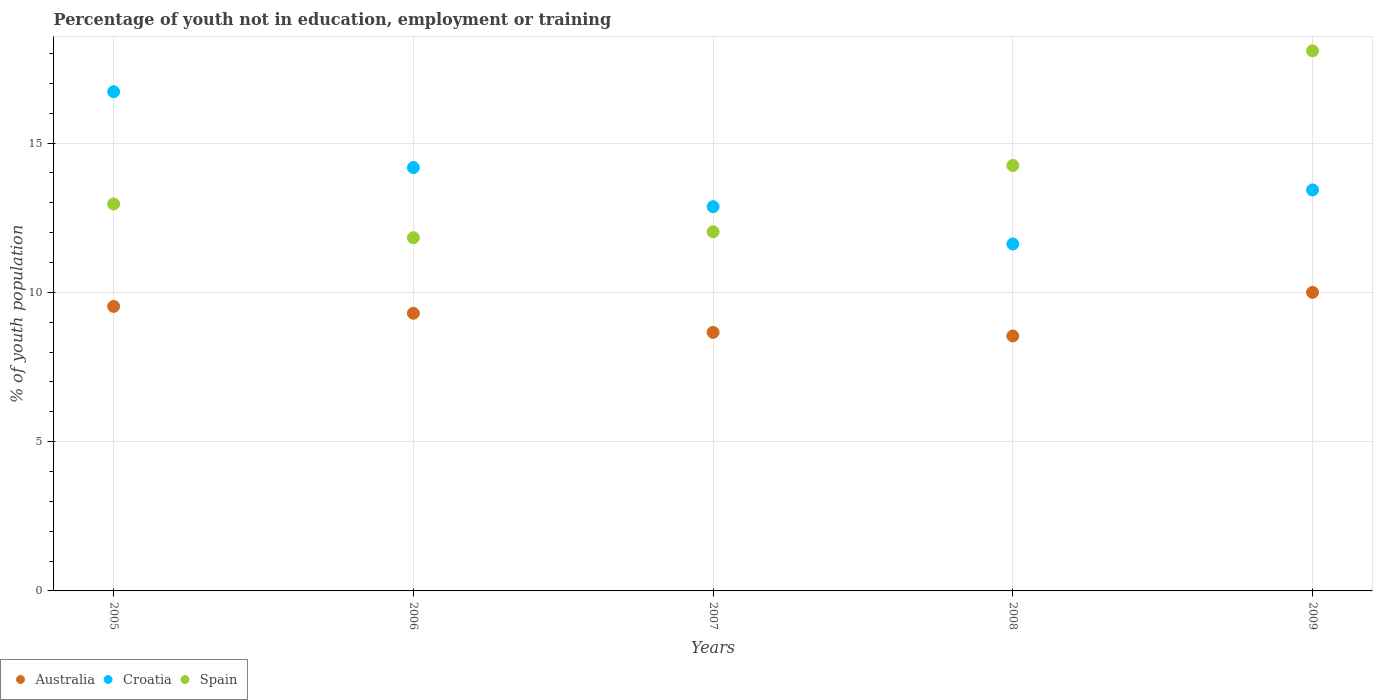What is the percentage of unemployed youth population in in Croatia in 2009?
Ensure brevity in your answer.  13.43. Across all years, what is the maximum percentage of unemployed youth population in in Croatia?
Ensure brevity in your answer.  16.72. Across all years, what is the minimum percentage of unemployed youth population in in Spain?
Offer a very short reply. 11.83. In which year was the percentage of unemployed youth population in in Australia minimum?
Provide a short and direct response. 2008. What is the total percentage of unemployed youth population in in Croatia in the graph?
Your answer should be very brief. 68.82. What is the difference between the percentage of unemployed youth population in in Australia in 2005 and that in 2006?
Provide a short and direct response. 0.23. What is the difference between the percentage of unemployed youth population in in Australia in 2007 and the percentage of unemployed youth population in in Spain in 2009?
Your response must be concise. -9.43. What is the average percentage of unemployed youth population in in Spain per year?
Offer a terse response. 13.83. In the year 2005, what is the difference between the percentage of unemployed youth population in in Spain and percentage of unemployed youth population in in Australia?
Offer a terse response. 3.43. In how many years, is the percentage of unemployed youth population in in Croatia greater than 17 %?
Offer a terse response. 0. What is the ratio of the percentage of unemployed youth population in in Australia in 2005 to that in 2008?
Your answer should be compact. 1.12. What is the difference between the highest and the second highest percentage of unemployed youth population in in Spain?
Give a very brief answer. 3.84. What is the difference between the highest and the lowest percentage of unemployed youth population in in Australia?
Provide a succinct answer. 1.46. Is the sum of the percentage of unemployed youth population in in Australia in 2006 and 2007 greater than the maximum percentage of unemployed youth population in in Croatia across all years?
Your answer should be compact. Yes. Is it the case that in every year, the sum of the percentage of unemployed youth population in in Spain and percentage of unemployed youth population in in Croatia  is greater than the percentage of unemployed youth population in in Australia?
Your answer should be compact. Yes. Does the percentage of unemployed youth population in in Australia monotonically increase over the years?
Your answer should be compact. No. Is the percentage of unemployed youth population in in Australia strictly greater than the percentage of unemployed youth population in in Spain over the years?
Ensure brevity in your answer.  No. Is the percentage of unemployed youth population in in Croatia strictly less than the percentage of unemployed youth population in in Australia over the years?
Provide a short and direct response. No. How many dotlines are there?
Provide a succinct answer. 3. What is the difference between two consecutive major ticks on the Y-axis?
Your response must be concise. 5. Are the values on the major ticks of Y-axis written in scientific E-notation?
Ensure brevity in your answer.  No. Where does the legend appear in the graph?
Offer a very short reply. Bottom left. How many legend labels are there?
Your response must be concise. 3. How are the legend labels stacked?
Make the answer very short. Horizontal. What is the title of the graph?
Your answer should be compact. Percentage of youth not in education, employment or training. What is the label or title of the Y-axis?
Ensure brevity in your answer.  % of youth population. What is the % of youth population in Australia in 2005?
Keep it short and to the point. 9.53. What is the % of youth population in Croatia in 2005?
Your answer should be compact. 16.72. What is the % of youth population in Spain in 2005?
Make the answer very short. 12.96. What is the % of youth population of Australia in 2006?
Give a very brief answer. 9.3. What is the % of youth population of Croatia in 2006?
Provide a succinct answer. 14.18. What is the % of youth population in Spain in 2006?
Your answer should be very brief. 11.83. What is the % of youth population in Australia in 2007?
Your answer should be compact. 8.66. What is the % of youth population of Croatia in 2007?
Provide a short and direct response. 12.87. What is the % of youth population of Spain in 2007?
Offer a terse response. 12.03. What is the % of youth population in Australia in 2008?
Your answer should be compact. 8.54. What is the % of youth population in Croatia in 2008?
Keep it short and to the point. 11.62. What is the % of youth population in Spain in 2008?
Your answer should be compact. 14.25. What is the % of youth population in Croatia in 2009?
Your answer should be very brief. 13.43. What is the % of youth population of Spain in 2009?
Ensure brevity in your answer.  18.09. Across all years, what is the maximum % of youth population of Australia?
Provide a short and direct response. 10. Across all years, what is the maximum % of youth population of Croatia?
Provide a short and direct response. 16.72. Across all years, what is the maximum % of youth population of Spain?
Offer a terse response. 18.09. Across all years, what is the minimum % of youth population of Australia?
Your answer should be very brief. 8.54. Across all years, what is the minimum % of youth population in Croatia?
Ensure brevity in your answer.  11.62. Across all years, what is the minimum % of youth population of Spain?
Give a very brief answer. 11.83. What is the total % of youth population in Australia in the graph?
Offer a terse response. 46.03. What is the total % of youth population in Croatia in the graph?
Keep it short and to the point. 68.82. What is the total % of youth population of Spain in the graph?
Your response must be concise. 69.16. What is the difference between the % of youth population of Australia in 2005 and that in 2006?
Offer a very short reply. 0.23. What is the difference between the % of youth population in Croatia in 2005 and that in 2006?
Give a very brief answer. 2.54. What is the difference between the % of youth population of Spain in 2005 and that in 2006?
Provide a short and direct response. 1.13. What is the difference between the % of youth population in Australia in 2005 and that in 2007?
Ensure brevity in your answer.  0.87. What is the difference between the % of youth population of Croatia in 2005 and that in 2007?
Your answer should be compact. 3.85. What is the difference between the % of youth population of Spain in 2005 and that in 2008?
Your response must be concise. -1.29. What is the difference between the % of youth population of Australia in 2005 and that in 2009?
Provide a short and direct response. -0.47. What is the difference between the % of youth population of Croatia in 2005 and that in 2009?
Give a very brief answer. 3.29. What is the difference between the % of youth population of Spain in 2005 and that in 2009?
Give a very brief answer. -5.13. What is the difference between the % of youth population in Australia in 2006 and that in 2007?
Your answer should be compact. 0.64. What is the difference between the % of youth population in Croatia in 2006 and that in 2007?
Your answer should be very brief. 1.31. What is the difference between the % of youth population in Spain in 2006 and that in 2007?
Give a very brief answer. -0.2. What is the difference between the % of youth population in Australia in 2006 and that in 2008?
Keep it short and to the point. 0.76. What is the difference between the % of youth population of Croatia in 2006 and that in 2008?
Give a very brief answer. 2.56. What is the difference between the % of youth population in Spain in 2006 and that in 2008?
Offer a very short reply. -2.42. What is the difference between the % of youth population of Australia in 2006 and that in 2009?
Provide a short and direct response. -0.7. What is the difference between the % of youth population of Spain in 2006 and that in 2009?
Your answer should be compact. -6.26. What is the difference between the % of youth population of Australia in 2007 and that in 2008?
Your answer should be very brief. 0.12. What is the difference between the % of youth population of Spain in 2007 and that in 2008?
Offer a terse response. -2.22. What is the difference between the % of youth population of Australia in 2007 and that in 2009?
Give a very brief answer. -1.34. What is the difference between the % of youth population in Croatia in 2007 and that in 2009?
Offer a terse response. -0.56. What is the difference between the % of youth population of Spain in 2007 and that in 2009?
Ensure brevity in your answer.  -6.06. What is the difference between the % of youth population of Australia in 2008 and that in 2009?
Keep it short and to the point. -1.46. What is the difference between the % of youth population of Croatia in 2008 and that in 2009?
Offer a very short reply. -1.81. What is the difference between the % of youth population of Spain in 2008 and that in 2009?
Provide a short and direct response. -3.84. What is the difference between the % of youth population of Australia in 2005 and the % of youth population of Croatia in 2006?
Provide a succinct answer. -4.65. What is the difference between the % of youth population in Croatia in 2005 and the % of youth population in Spain in 2006?
Give a very brief answer. 4.89. What is the difference between the % of youth population in Australia in 2005 and the % of youth population in Croatia in 2007?
Ensure brevity in your answer.  -3.34. What is the difference between the % of youth population of Croatia in 2005 and the % of youth population of Spain in 2007?
Make the answer very short. 4.69. What is the difference between the % of youth population in Australia in 2005 and the % of youth population in Croatia in 2008?
Give a very brief answer. -2.09. What is the difference between the % of youth population of Australia in 2005 and the % of youth population of Spain in 2008?
Your answer should be very brief. -4.72. What is the difference between the % of youth population of Croatia in 2005 and the % of youth population of Spain in 2008?
Provide a short and direct response. 2.47. What is the difference between the % of youth population of Australia in 2005 and the % of youth population of Spain in 2009?
Provide a short and direct response. -8.56. What is the difference between the % of youth population of Croatia in 2005 and the % of youth population of Spain in 2009?
Offer a very short reply. -1.37. What is the difference between the % of youth population of Australia in 2006 and the % of youth population of Croatia in 2007?
Keep it short and to the point. -3.57. What is the difference between the % of youth population in Australia in 2006 and the % of youth population in Spain in 2007?
Offer a very short reply. -2.73. What is the difference between the % of youth population of Croatia in 2006 and the % of youth population of Spain in 2007?
Your answer should be very brief. 2.15. What is the difference between the % of youth population in Australia in 2006 and the % of youth population in Croatia in 2008?
Ensure brevity in your answer.  -2.32. What is the difference between the % of youth population in Australia in 2006 and the % of youth population in Spain in 2008?
Provide a succinct answer. -4.95. What is the difference between the % of youth population in Croatia in 2006 and the % of youth population in Spain in 2008?
Offer a very short reply. -0.07. What is the difference between the % of youth population in Australia in 2006 and the % of youth population in Croatia in 2009?
Make the answer very short. -4.13. What is the difference between the % of youth population of Australia in 2006 and the % of youth population of Spain in 2009?
Your response must be concise. -8.79. What is the difference between the % of youth population in Croatia in 2006 and the % of youth population in Spain in 2009?
Offer a terse response. -3.91. What is the difference between the % of youth population of Australia in 2007 and the % of youth population of Croatia in 2008?
Offer a terse response. -2.96. What is the difference between the % of youth population in Australia in 2007 and the % of youth population in Spain in 2008?
Provide a short and direct response. -5.59. What is the difference between the % of youth population in Croatia in 2007 and the % of youth population in Spain in 2008?
Keep it short and to the point. -1.38. What is the difference between the % of youth population of Australia in 2007 and the % of youth population of Croatia in 2009?
Your response must be concise. -4.77. What is the difference between the % of youth population in Australia in 2007 and the % of youth population in Spain in 2009?
Provide a succinct answer. -9.43. What is the difference between the % of youth population of Croatia in 2007 and the % of youth population of Spain in 2009?
Give a very brief answer. -5.22. What is the difference between the % of youth population in Australia in 2008 and the % of youth population in Croatia in 2009?
Give a very brief answer. -4.89. What is the difference between the % of youth population of Australia in 2008 and the % of youth population of Spain in 2009?
Give a very brief answer. -9.55. What is the difference between the % of youth population in Croatia in 2008 and the % of youth population in Spain in 2009?
Keep it short and to the point. -6.47. What is the average % of youth population of Australia per year?
Offer a terse response. 9.21. What is the average % of youth population of Croatia per year?
Your answer should be very brief. 13.76. What is the average % of youth population in Spain per year?
Make the answer very short. 13.83. In the year 2005, what is the difference between the % of youth population of Australia and % of youth population of Croatia?
Provide a short and direct response. -7.19. In the year 2005, what is the difference between the % of youth population of Australia and % of youth population of Spain?
Make the answer very short. -3.43. In the year 2005, what is the difference between the % of youth population in Croatia and % of youth population in Spain?
Make the answer very short. 3.76. In the year 2006, what is the difference between the % of youth population of Australia and % of youth population of Croatia?
Make the answer very short. -4.88. In the year 2006, what is the difference between the % of youth population in Australia and % of youth population in Spain?
Keep it short and to the point. -2.53. In the year 2006, what is the difference between the % of youth population in Croatia and % of youth population in Spain?
Ensure brevity in your answer.  2.35. In the year 2007, what is the difference between the % of youth population in Australia and % of youth population in Croatia?
Offer a very short reply. -4.21. In the year 2007, what is the difference between the % of youth population of Australia and % of youth population of Spain?
Ensure brevity in your answer.  -3.37. In the year 2007, what is the difference between the % of youth population of Croatia and % of youth population of Spain?
Offer a very short reply. 0.84. In the year 2008, what is the difference between the % of youth population of Australia and % of youth population of Croatia?
Offer a very short reply. -3.08. In the year 2008, what is the difference between the % of youth population in Australia and % of youth population in Spain?
Offer a terse response. -5.71. In the year 2008, what is the difference between the % of youth population in Croatia and % of youth population in Spain?
Provide a short and direct response. -2.63. In the year 2009, what is the difference between the % of youth population in Australia and % of youth population in Croatia?
Ensure brevity in your answer.  -3.43. In the year 2009, what is the difference between the % of youth population in Australia and % of youth population in Spain?
Give a very brief answer. -8.09. In the year 2009, what is the difference between the % of youth population of Croatia and % of youth population of Spain?
Give a very brief answer. -4.66. What is the ratio of the % of youth population of Australia in 2005 to that in 2006?
Your answer should be very brief. 1.02. What is the ratio of the % of youth population of Croatia in 2005 to that in 2006?
Your answer should be compact. 1.18. What is the ratio of the % of youth population in Spain in 2005 to that in 2006?
Offer a very short reply. 1.1. What is the ratio of the % of youth population in Australia in 2005 to that in 2007?
Your answer should be compact. 1.1. What is the ratio of the % of youth population in Croatia in 2005 to that in 2007?
Your answer should be very brief. 1.3. What is the ratio of the % of youth population of Spain in 2005 to that in 2007?
Provide a succinct answer. 1.08. What is the ratio of the % of youth population of Australia in 2005 to that in 2008?
Your answer should be compact. 1.12. What is the ratio of the % of youth population of Croatia in 2005 to that in 2008?
Your answer should be very brief. 1.44. What is the ratio of the % of youth population of Spain in 2005 to that in 2008?
Offer a terse response. 0.91. What is the ratio of the % of youth population in Australia in 2005 to that in 2009?
Offer a terse response. 0.95. What is the ratio of the % of youth population of Croatia in 2005 to that in 2009?
Provide a short and direct response. 1.25. What is the ratio of the % of youth population in Spain in 2005 to that in 2009?
Give a very brief answer. 0.72. What is the ratio of the % of youth population of Australia in 2006 to that in 2007?
Keep it short and to the point. 1.07. What is the ratio of the % of youth population of Croatia in 2006 to that in 2007?
Provide a succinct answer. 1.1. What is the ratio of the % of youth population of Spain in 2006 to that in 2007?
Provide a short and direct response. 0.98. What is the ratio of the % of youth population in Australia in 2006 to that in 2008?
Offer a terse response. 1.09. What is the ratio of the % of youth population of Croatia in 2006 to that in 2008?
Offer a terse response. 1.22. What is the ratio of the % of youth population of Spain in 2006 to that in 2008?
Ensure brevity in your answer.  0.83. What is the ratio of the % of youth population in Croatia in 2006 to that in 2009?
Offer a very short reply. 1.06. What is the ratio of the % of youth population in Spain in 2006 to that in 2009?
Offer a terse response. 0.65. What is the ratio of the % of youth population in Australia in 2007 to that in 2008?
Offer a terse response. 1.01. What is the ratio of the % of youth population of Croatia in 2007 to that in 2008?
Offer a terse response. 1.11. What is the ratio of the % of youth population in Spain in 2007 to that in 2008?
Give a very brief answer. 0.84. What is the ratio of the % of youth population in Australia in 2007 to that in 2009?
Keep it short and to the point. 0.87. What is the ratio of the % of youth population in Croatia in 2007 to that in 2009?
Keep it short and to the point. 0.96. What is the ratio of the % of youth population of Spain in 2007 to that in 2009?
Keep it short and to the point. 0.67. What is the ratio of the % of youth population of Australia in 2008 to that in 2009?
Give a very brief answer. 0.85. What is the ratio of the % of youth population in Croatia in 2008 to that in 2009?
Provide a succinct answer. 0.87. What is the ratio of the % of youth population of Spain in 2008 to that in 2009?
Provide a succinct answer. 0.79. What is the difference between the highest and the second highest % of youth population in Australia?
Your answer should be very brief. 0.47. What is the difference between the highest and the second highest % of youth population in Croatia?
Ensure brevity in your answer.  2.54. What is the difference between the highest and the second highest % of youth population of Spain?
Offer a terse response. 3.84. What is the difference between the highest and the lowest % of youth population of Australia?
Provide a succinct answer. 1.46. What is the difference between the highest and the lowest % of youth population in Spain?
Make the answer very short. 6.26. 